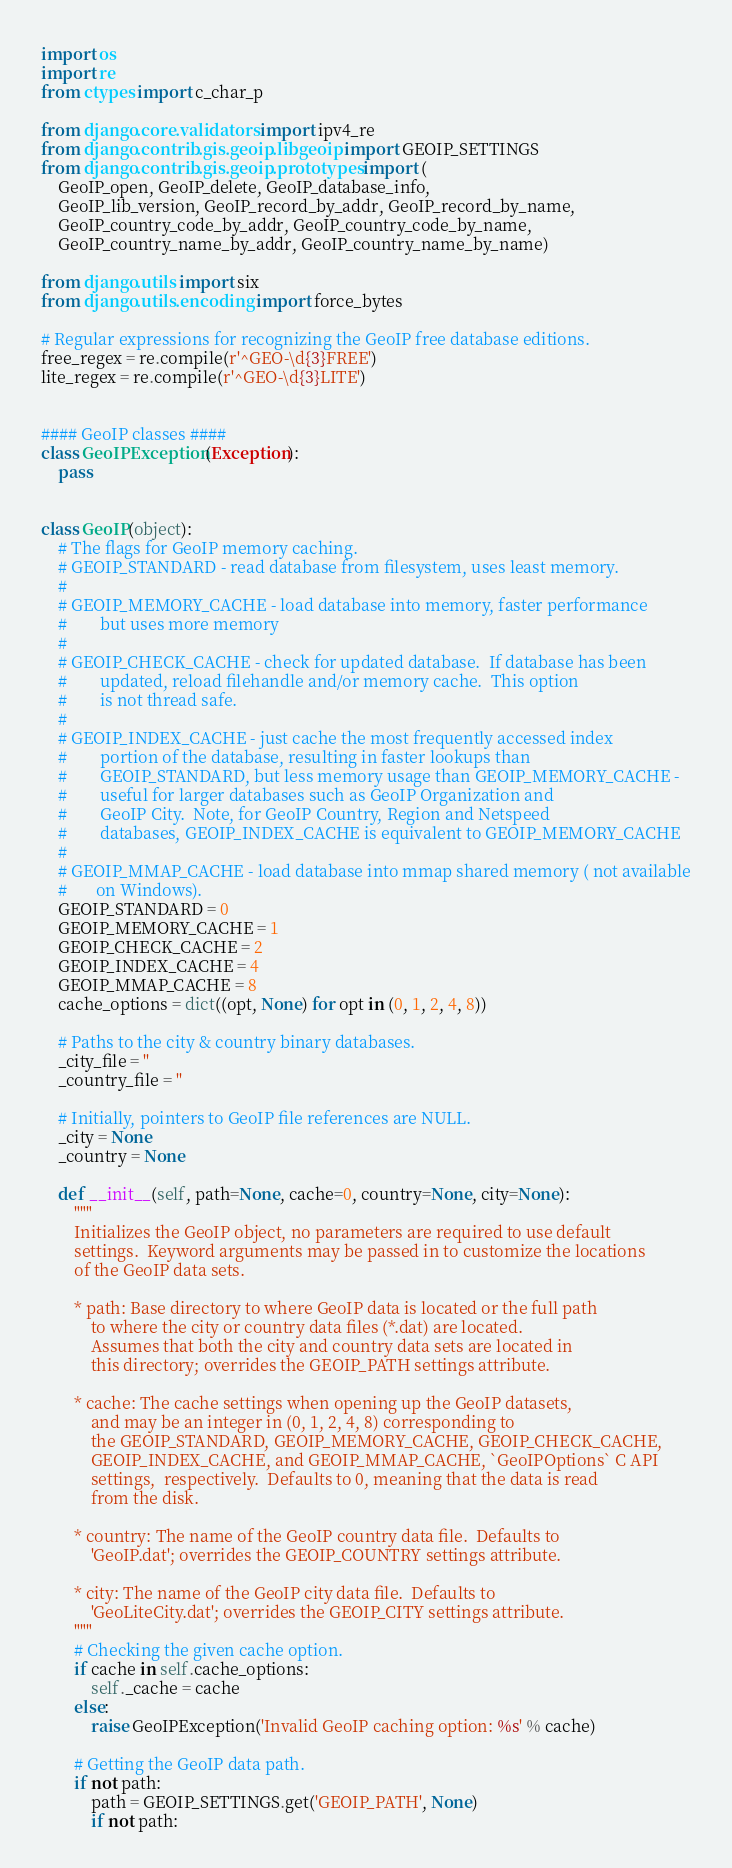<code> <loc_0><loc_0><loc_500><loc_500><_Python_>import os
import re
from ctypes import c_char_p

from django.core.validators import ipv4_re
from django.contrib.gis.geoip.libgeoip import GEOIP_SETTINGS
from django.contrib.gis.geoip.prototypes import (
    GeoIP_open, GeoIP_delete, GeoIP_database_info,
    GeoIP_lib_version, GeoIP_record_by_addr, GeoIP_record_by_name,
    GeoIP_country_code_by_addr, GeoIP_country_code_by_name,
    GeoIP_country_name_by_addr, GeoIP_country_name_by_name)

from django.utils import six
from django.utils.encoding import force_bytes

# Regular expressions for recognizing the GeoIP free database editions.
free_regex = re.compile(r'^GEO-\d{3}FREE')
lite_regex = re.compile(r'^GEO-\d{3}LITE')


#### GeoIP classes ####
class GeoIPException(Exception):
    pass


class GeoIP(object):
    # The flags for GeoIP memory caching.
    # GEOIP_STANDARD - read database from filesystem, uses least memory.
    #
    # GEOIP_MEMORY_CACHE - load database into memory, faster performance
    #        but uses more memory
    #
    # GEOIP_CHECK_CACHE - check for updated database.  If database has been
    #        updated, reload filehandle and/or memory cache.  This option
    #        is not thread safe.
    #
    # GEOIP_INDEX_CACHE - just cache the most frequently accessed index
    #        portion of the database, resulting in faster lookups than
    #        GEOIP_STANDARD, but less memory usage than GEOIP_MEMORY_CACHE -
    #        useful for larger databases such as GeoIP Organization and
    #        GeoIP City.  Note, for GeoIP Country, Region and Netspeed
    #        databases, GEOIP_INDEX_CACHE is equivalent to GEOIP_MEMORY_CACHE
    #
    # GEOIP_MMAP_CACHE - load database into mmap shared memory ( not available
    #       on Windows).
    GEOIP_STANDARD = 0
    GEOIP_MEMORY_CACHE = 1
    GEOIP_CHECK_CACHE = 2
    GEOIP_INDEX_CACHE = 4
    GEOIP_MMAP_CACHE = 8
    cache_options = dict((opt, None) for opt in (0, 1, 2, 4, 8))

    # Paths to the city & country binary databases.
    _city_file = ''
    _country_file = ''

    # Initially, pointers to GeoIP file references are NULL.
    _city = None
    _country = None

    def __init__(self, path=None, cache=0, country=None, city=None):
        """
        Initializes the GeoIP object, no parameters are required to use default
        settings.  Keyword arguments may be passed in to customize the locations
        of the GeoIP data sets.

        * path: Base directory to where GeoIP data is located or the full path
            to where the city or country data files (*.dat) are located.
            Assumes that both the city and country data sets are located in
            this directory; overrides the GEOIP_PATH settings attribute.

        * cache: The cache settings when opening up the GeoIP datasets,
            and may be an integer in (0, 1, 2, 4, 8) corresponding to
            the GEOIP_STANDARD, GEOIP_MEMORY_CACHE, GEOIP_CHECK_CACHE,
            GEOIP_INDEX_CACHE, and GEOIP_MMAP_CACHE, `GeoIPOptions` C API
            settings,  respectively.  Defaults to 0, meaning that the data is read
            from the disk.

        * country: The name of the GeoIP country data file.  Defaults to
            'GeoIP.dat'; overrides the GEOIP_COUNTRY settings attribute.

        * city: The name of the GeoIP city data file.  Defaults to
            'GeoLiteCity.dat'; overrides the GEOIP_CITY settings attribute.
        """
        # Checking the given cache option.
        if cache in self.cache_options:
            self._cache = cache
        else:
            raise GeoIPException('Invalid GeoIP caching option: %s' % cache)

        # Getting the GeoIP data path.
        if not path:
            path = GEOIP_SETTINGS.get('GEOIP_PATH', None)
            if not path:</code> 